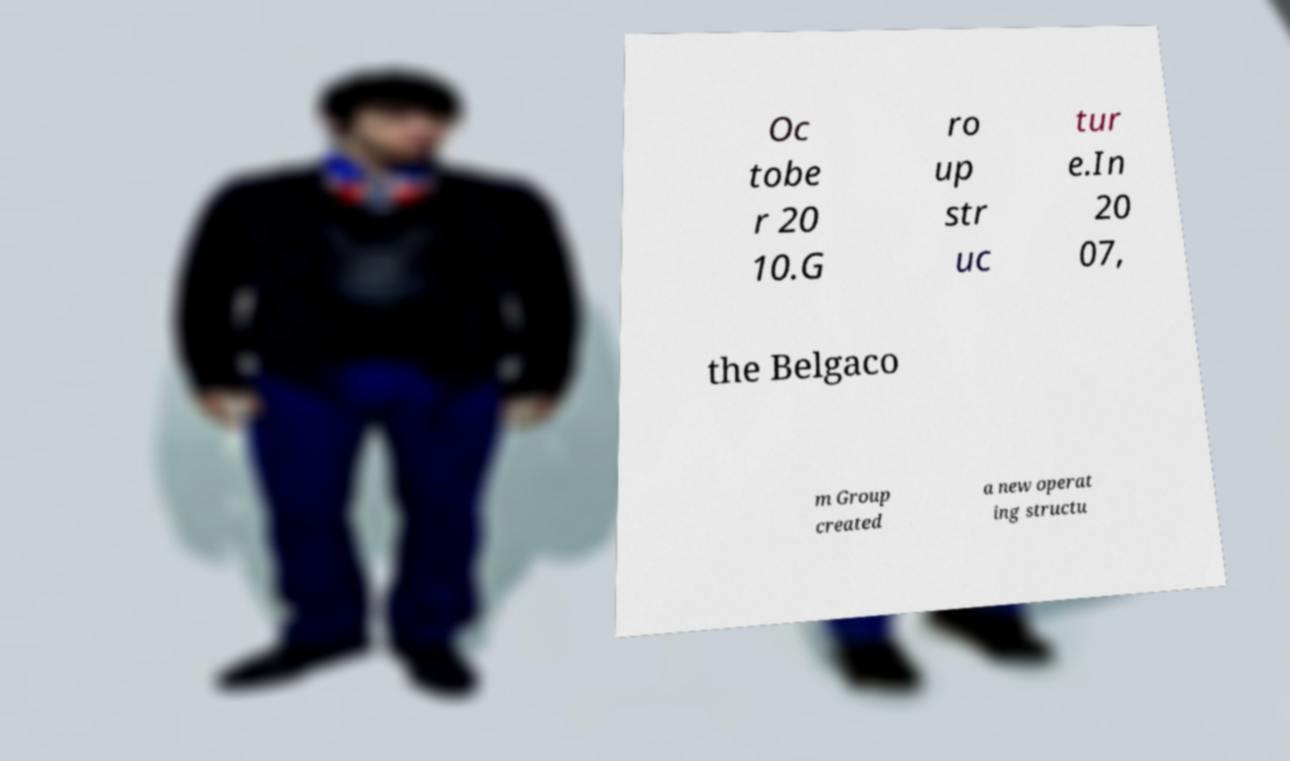Could you extract and type out the text from this image? Oc tobe r 20 10.G ro up str uc tur e.In 20 07, the Belgaco m Group created a new operat ing structu 